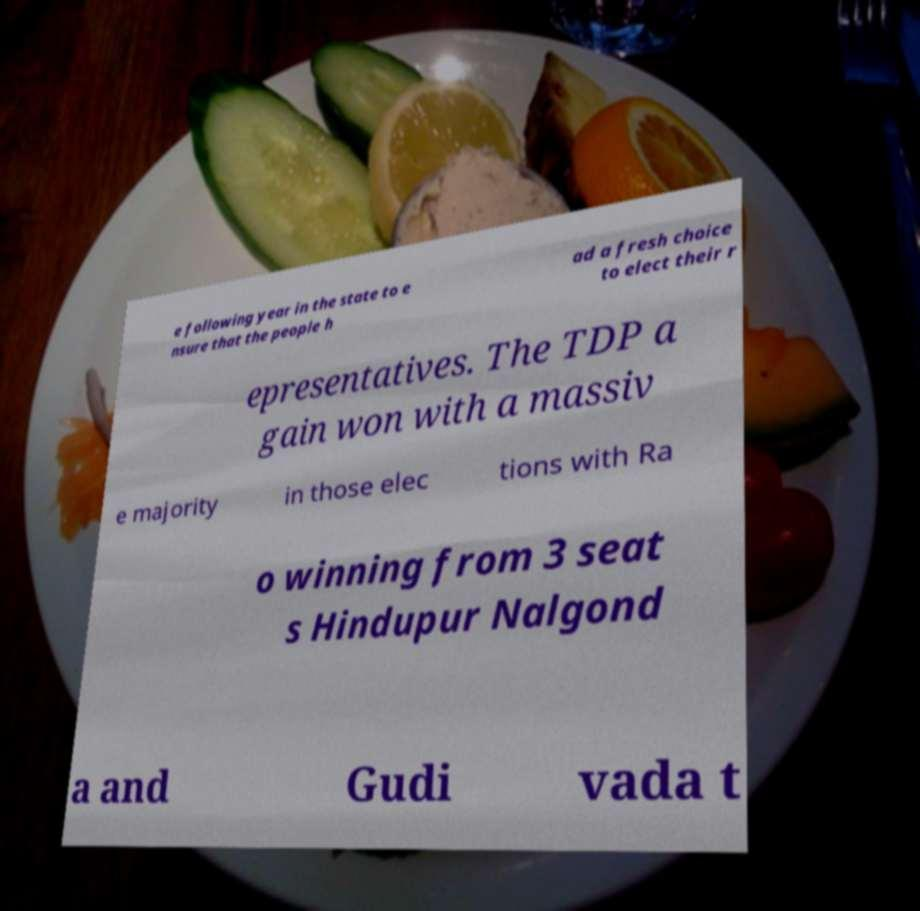For documentation purposes, I need the text within this image transcribed. Could you provide that? e following year in the state to e nsure that the people h ad a fresh choice to elect their r epresentatives. The TDP a gain won with a massiv e majority in those elec tions with Ra o winning from 3 seat s Hindupur Nalgond a and Gudi vada t 